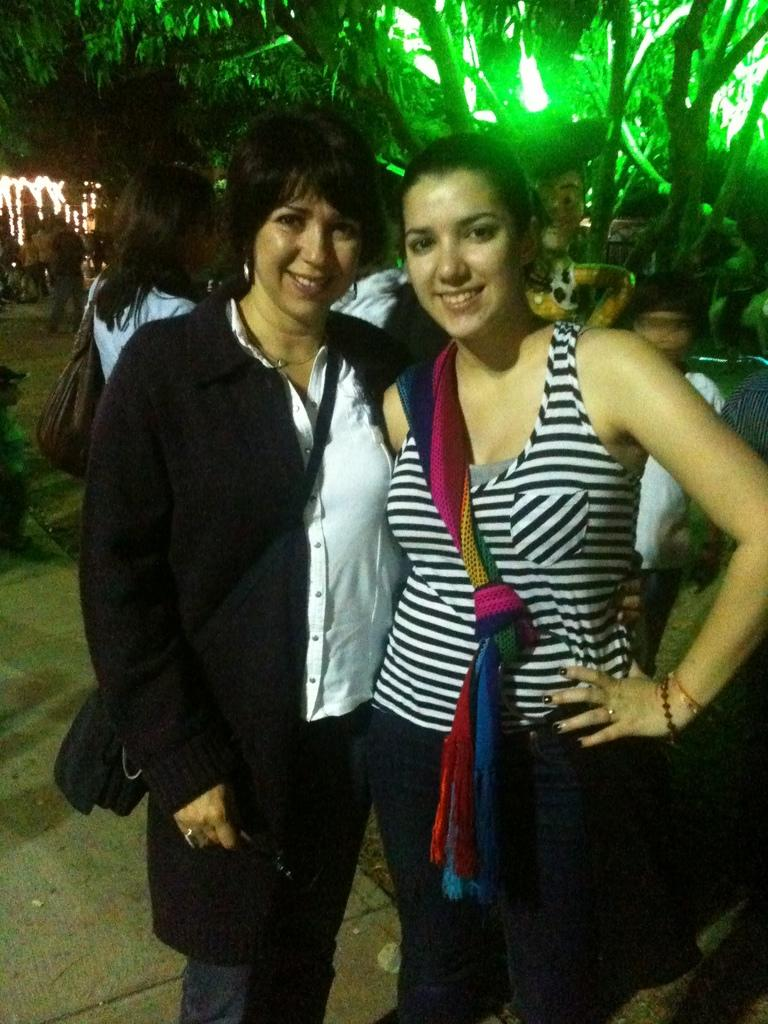How many women are in the image? There are two women in the image. What expressions do the women have? Both women are smiling. Can you describe the clothing of one of the women? One of the women is wearing a bag. What is the woman wearing a bag doing? The woman wearing a bag is holding an object. What can be seen in the background of the image? There are people, trees, and lights visible in the background of the image. What type of kite is being flown by the women in the image? There is no kite present in the image; the women are not flying a kite. What is the current weather condition in the image? The provided facts do not mention any weather conditions, so it cannot be determined from the image. 